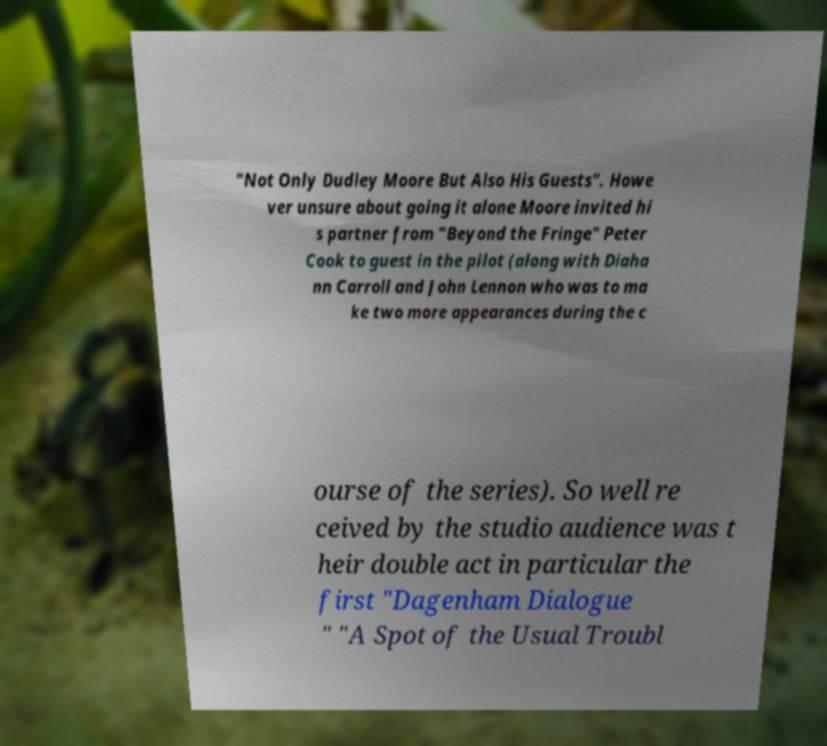Please read and relay the text visible in this image. What does it say? "Not Only Dudley Moore But Also His Guests". Howe ver unsure about going it alone Moore invited hi s partner from "Beyond the Fringe" Peter Cook to guest in the pilot (along with Diaha nn Carroll and John Lennon who was to ma ke two more appearances during the c ourse of the series). So well re ceived by the studio audience was t heir double act in particular the first "Dagenham Dialogue " "A Spot of the Usual Troubl 